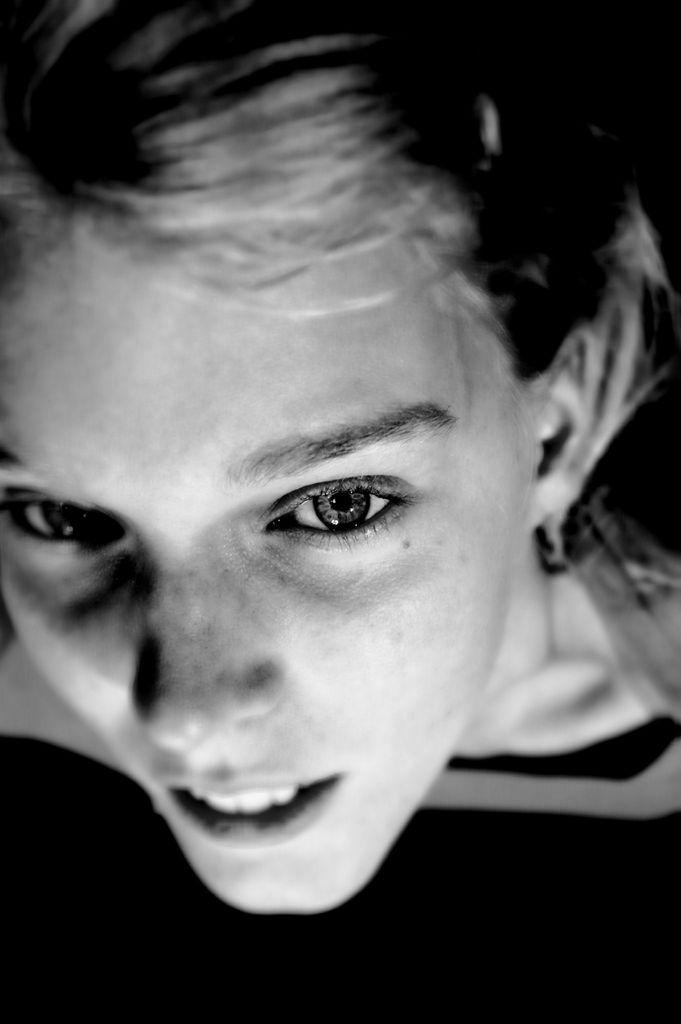What is the main subject of the image? The main subject of the image is the face of a girl. What color scheme is used in the image? The image is in black and white color. Where is the playground located in the image? There is no playground present in the image; it only features the face of a girl. What is the girl doing with her arm in the image? There is no arm visible in the image, as it only shows the girl's face. 